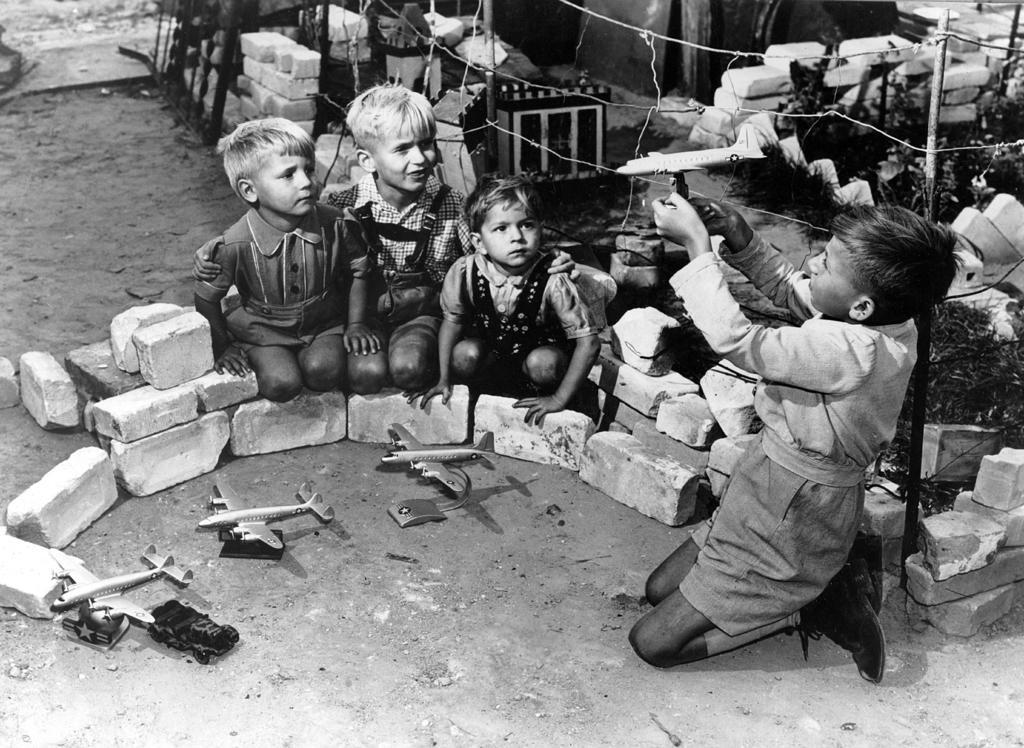Describe this image in one or two sentences. In this image I can see few people sitting and one person is holding something. I can see few aeroplanes,stones and few objects on the ground. The image is in black and white. 